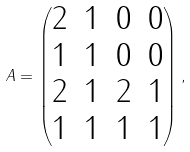<formula> <loc_0><loc_0><loc_500><loc_500>A = \begin{pmatrix} 2 & 1 & 0 & 0 \\ 1 & 1 & 0 & 0 \\ 2 & 1 & 2 & 1 \\ 1 & 1 & 1 & 1 \end{pmatrix} ,</formula> 